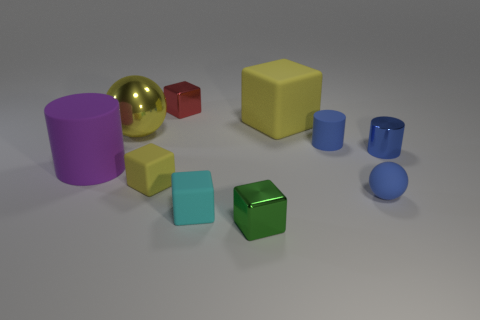There is a big matte object to the right of the large sphere; does it have the same shape as the purple rubber thing?
Offer a terse response. No. What number of things are either big yellow matte objects or small things that are behind the blue ball?
Your answer should be very brief. 5. Are there fewer large objects than big red shiny cylinders?
Provide a short and direct response. No. Is the number of red metal cylinders greater than the number of yellow metallic spheres?
Offer a very short reply. No. What number of other objects are the same material as the big yellow ball?
Your response must be concise. 3. How many large yellow metal balls are right of the tiny rubber cylinder that is on the right side of the large yellow object to the right of the tiny cyan matte block?
Provide a succinct answer. 0. How many rubber things are either small balls or brown cylinders?
Offer a terse response. 1. There is a yellow metallic thing that is to the left of the small blue rubber thing in front of the blue rubber cylinder; how big is it?
Offer a terse response. Large. Do the tiny cylinder behind the small blue shiny cylinder and the thing on the right side of the blue matte ball have the same color?
Your answer should be compact. Yes. There is a cube that is both behind the rubber ball and on the right side of the tiny red block; what is its color?
Keep it short and to the point. Yellow. 